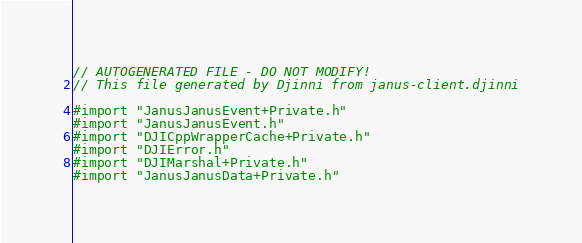<code> <loc_0><loc_0><loc_500><loc_500><_ObjectiveC_>// AUTOGENERATED FILE - DO NOT MODIFY!
// This file generated by Djinni from janus-client.djinni

#import "JanusJanusEvent+Private.h"
#import "JanusJanusEvent.h"
#import "DJICppWrapperCache+Private.h"
#import "DJIError.h"
#import "DJIMarshal+Private.h"
#import "JanusJanusData+Private.h"</code> 